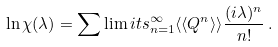<formula> <loc_0><loc_0><loc_500><loc_500>\ln \chi ( \lambda ) = \sum \lim i t s _ { n = 1 } ^ { \infty } \langle \langle Q ^ { n } \rangle \rangle \frac { ( i \lambda ) ^ { n } } { n ! } \, .</formula> 